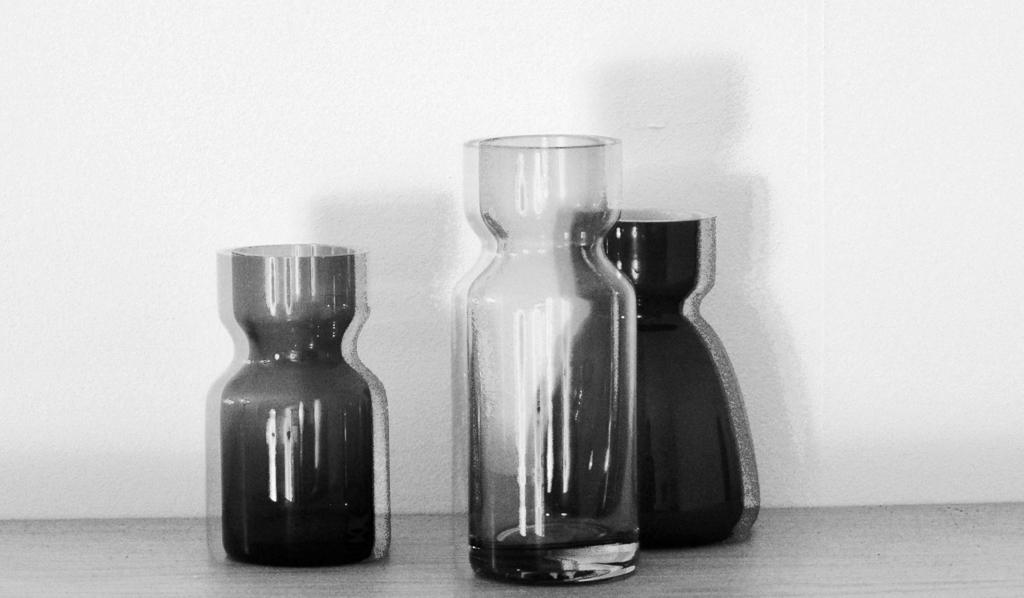Describe this image in one or two sentences. It is the black and white image in which there are three glass flasks on the floor. 